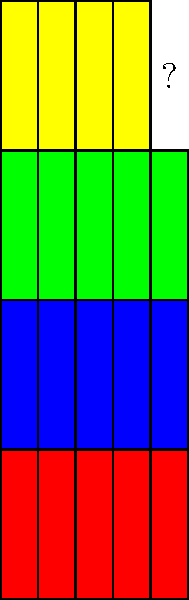The image represents a simplified view of genomic sequences from four different coronavirus strains, with each colored block representing a specific gene segment. Based on the pattern observed in the first three rows, what color should the block with the question mark be? To determine the color of the missing block, we need to analyze the pattern in the genomic sequences:

1. Each row represents a different coronavirus strain.
2. Each colored block represents a specific gene segment.
3. The pattern repeats for the first three strains (rows):
   - Row 1 (bottom): 5 red blocks
   - Row 2: 5 blue blocks
   - Row 3: 5 green blocks
4. The fourth row (top) follows the same pattern but is incomplete:
   - It has 4 yellow blocks, with the 5th block missing
5. Given the consistent pattern of 5 blocks per strain and the repetition of colors within each strain, we can conclude that the missing block should maintain the pattern established in the fourth row.

Therefore, the missing block should be yellow to complete the pattern of 5 yellow blocks for the fourth coronavirus strain.
Answer: Yellow 